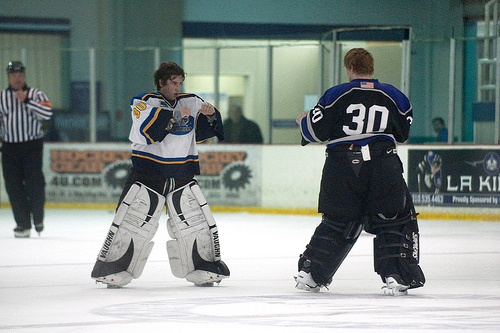<image>
Is the man behind the fence? No. The man is not behind the fence. From this viewpoint, the man appears to be positioned elsewhere in the scene. Where is the man in relation to the man? Is it to the right of the man? No. The man is not to the right of the man. The horizontal positioning shows a different relationship. Is the window in front of the hockey player? No. The window is not in front of the hockey player. The spatial positioning shows a different relationship between these objects. 